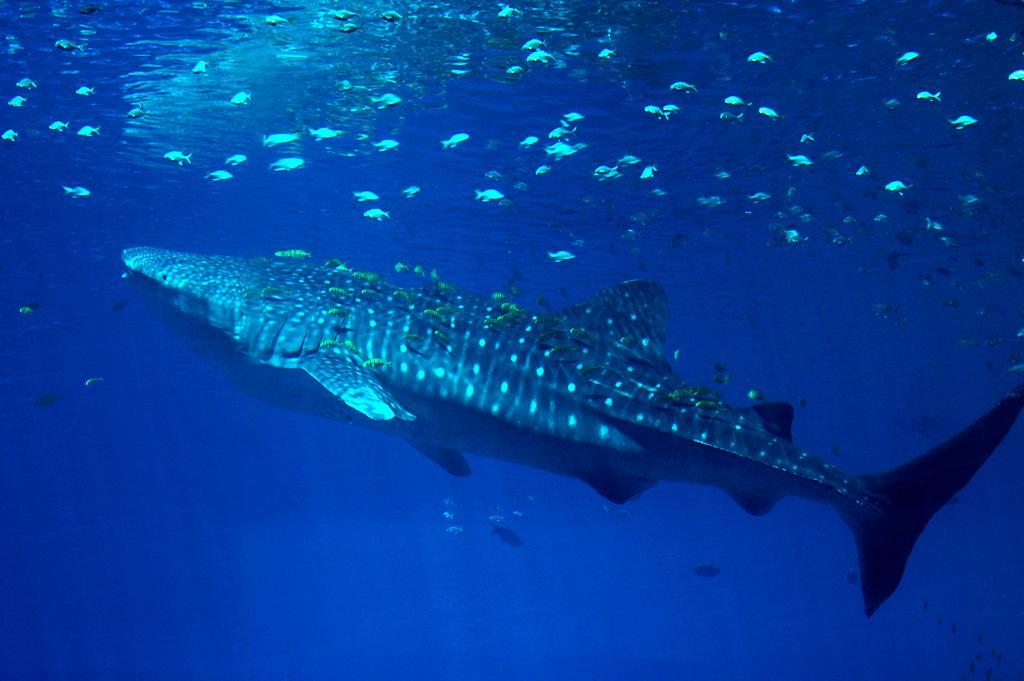Can you describe this image briefly? In this image there is a big fish in the water. There are few small fishes around it. 